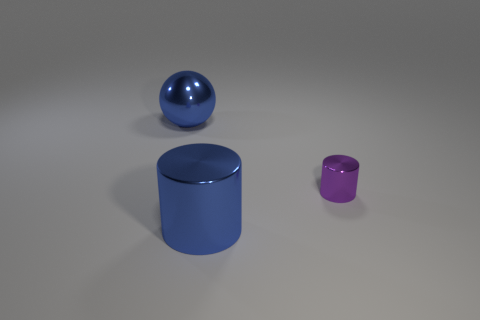Add 3 large blue metal objects. How many objects exist? 6 Subtract all balls. How many objects are left? 2 Subtract all blue cylinders. How many cylinders are left? 1 Subtract 0 purple spheres. How many objects are left? 3 Subtract 1 cylinders. How many cylinders are left? 1 Subtract all gray cylinders. Subtract all green blocks. How many cylinders are left? 2 Subtract all yellow blocks. How many purple cylinders are left? 1 Subtract all metallic objects. Subtract all small cyan cylinders. How many objects are left? 0 Add 1 blue metal cylinders. How many blue metal cylinders are left? 2 Add 3 blocks. How many blocks exist? 3 